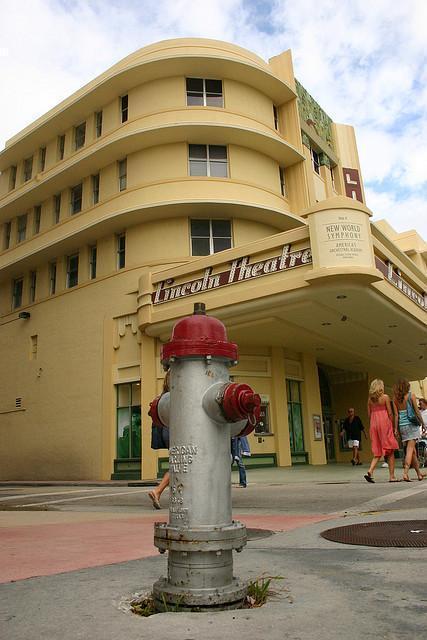What could someone do inside the yellow building?
Choose the right answer from the provided options to respond to the question.
Options: Mail letters, buy clothing, watch movie, exercise. Watch movie. 